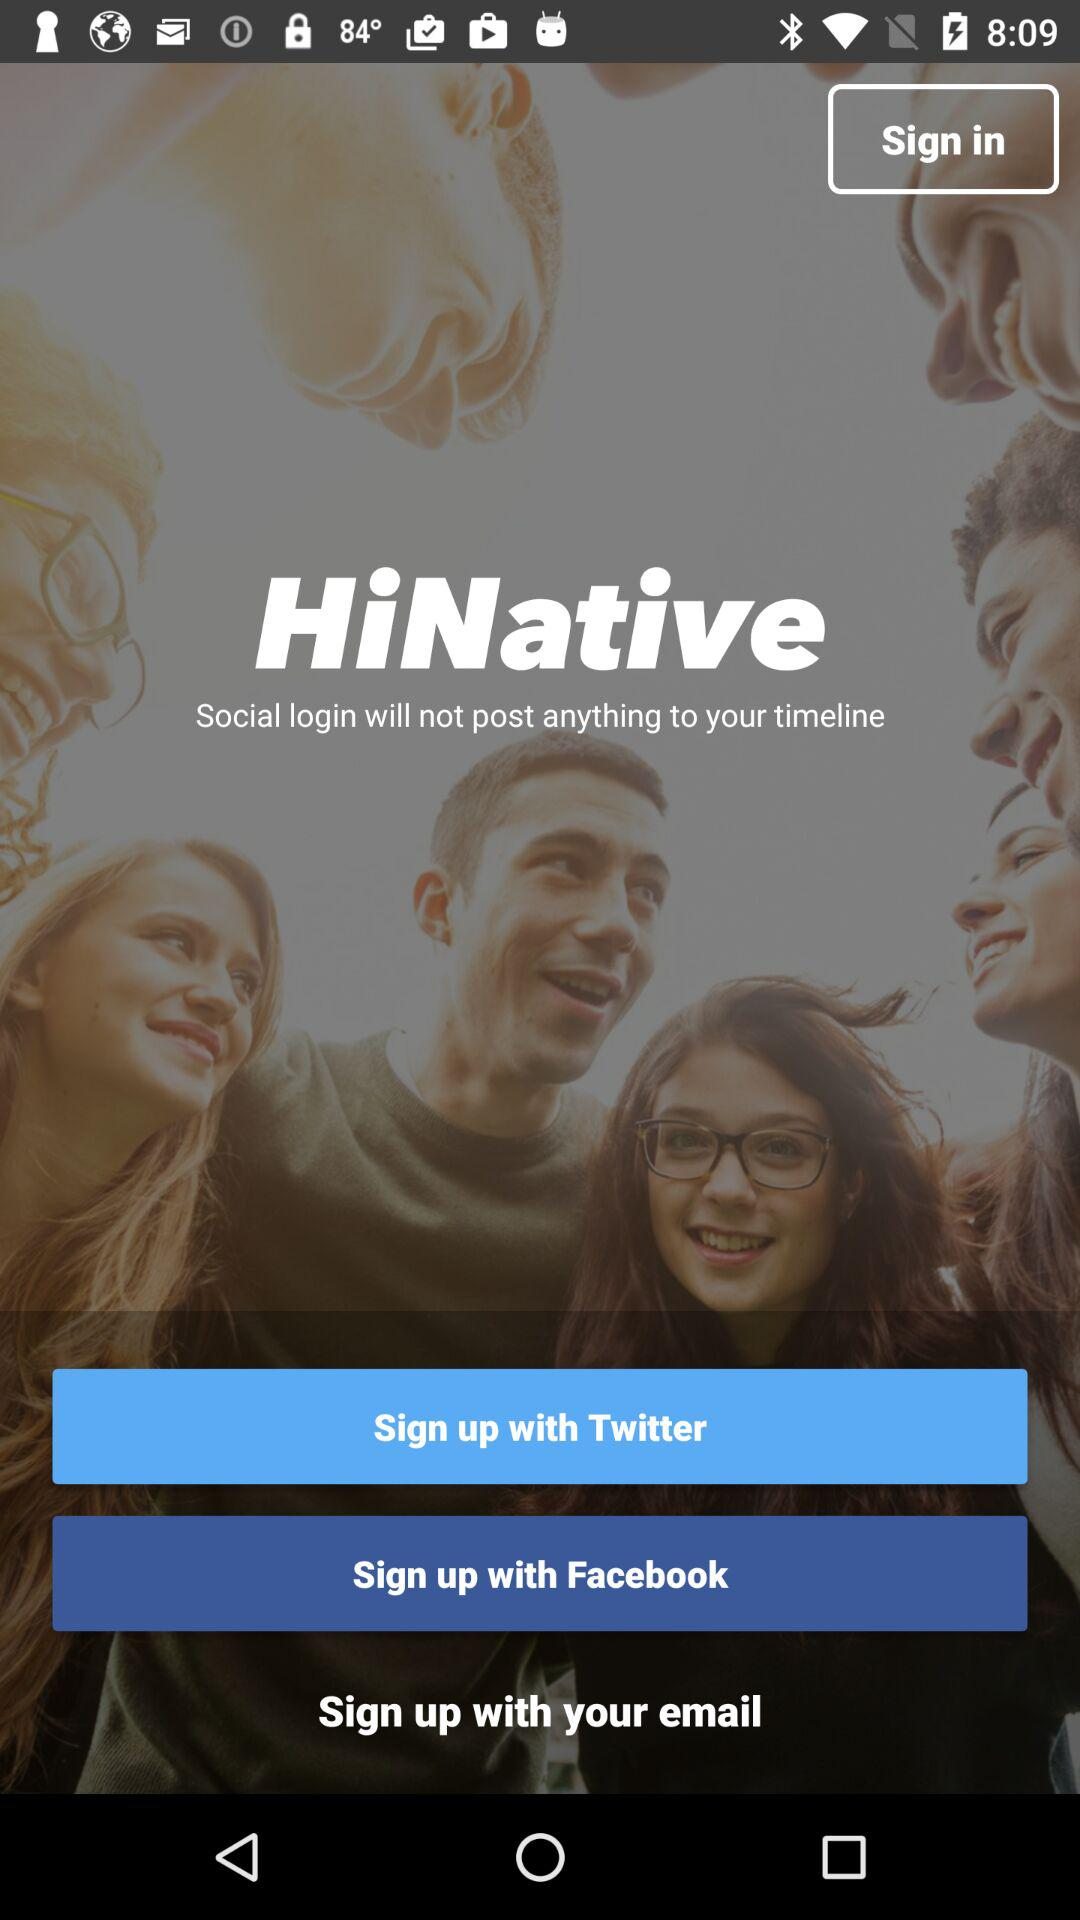Through which applications can we sign up? You can sign up through "Twitter" and "Facebook". 